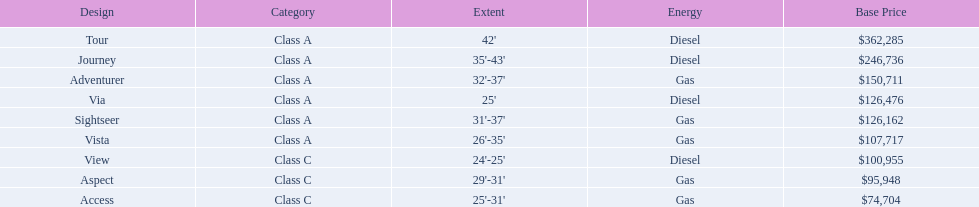What is the highest price of a winnebago model? $362,285. What is the name of the vehicle with this price? Tour. 